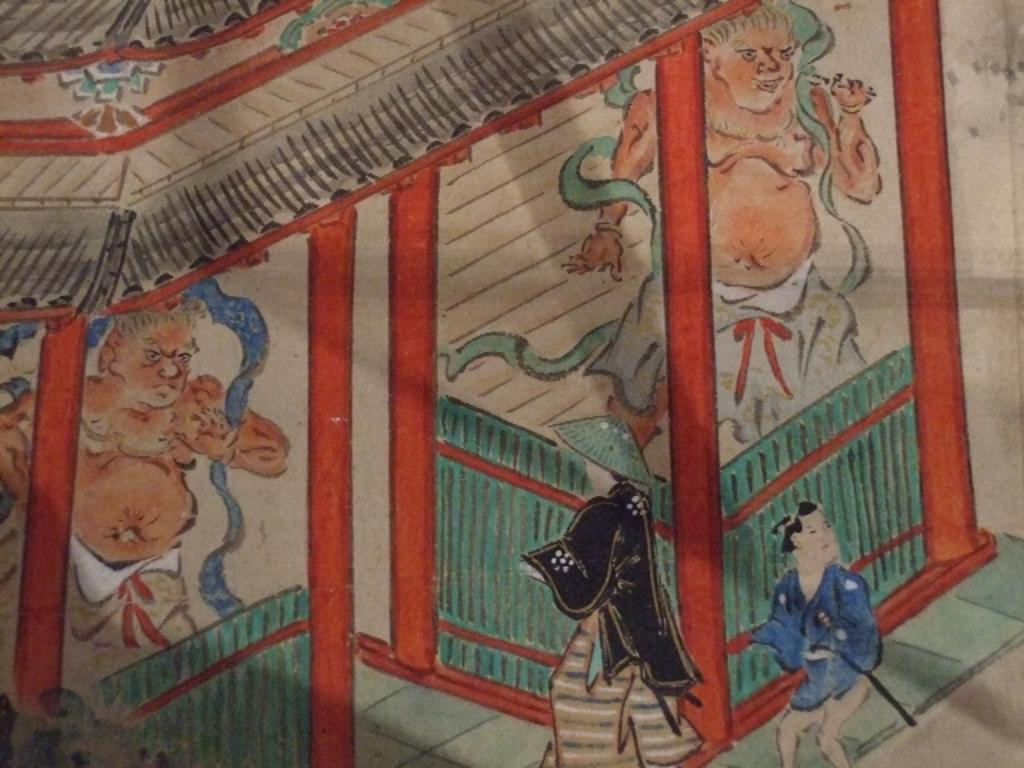Who or what can be seen in the image? There are persons depicted in the image. What type of structure is present in the image? There is a shelter in the image. What type of clocks can be seen hanging from the persons' necks in the image? There are no clocks visible in the image; the persons are not wearing any. What type of food is being prepared or served in the image? There is no food present in the image. 